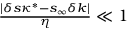Convert formula to latex. <formula><loc_0><loc_0><loc_500><loc_500>\begin{array} { r } { \frac { | \delta s \kappa ^ { * } - s _ { \infty } \delta k | } { \eta } \ll 1 } \end{array}</formula> 